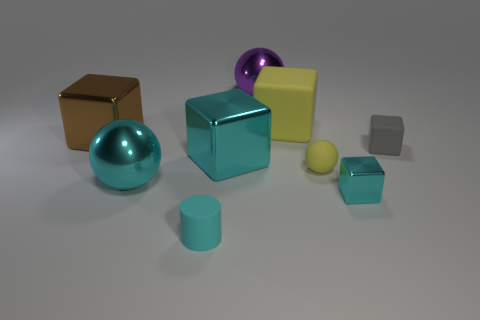Does the small rubber sphere have the same color as the large shiny sphere right of the cyan matte cylinder?
Your answer should be compact. No. There is a matte object that is the same shape as the large purple metal thing; what is its size?
Provide a short and direct response. Small. What shape is the cyan metallic thing that is both to the left of the yellow matte ball and in front of the small yellow matte thing?
Make the answer very short. Sphere. There is a purple metal thing; does it have the same size as the cyan metallic object that is to the left of the cyan matte cylinder?
Ensure brevity in your answer.  Yes. What color is the other small metal object that is the same shape as the brown metallic thing?
Your answer should be compact. Cyan. There is a rubber block that is on the right side of the big yellow object; does it have the same size as the metallic ball that is right of the cylinder?
Keep it short and to the point. No. Do the small cyan metallic object and the tiny gray matte object have the same shape?
Your answer should be very brief. Yes. What number of objects are either large things in front of the tiny gray cube or large brown metal balls?
Ensure brevity in your answer.  2. Is there a tiny purple object of the same shape as the big rubber object?
Make the answer very short. No. Is the number of cylinders that are on the right side of the cyan cylinder the same as the number of small cylinders?
Make the answer very short. No. 